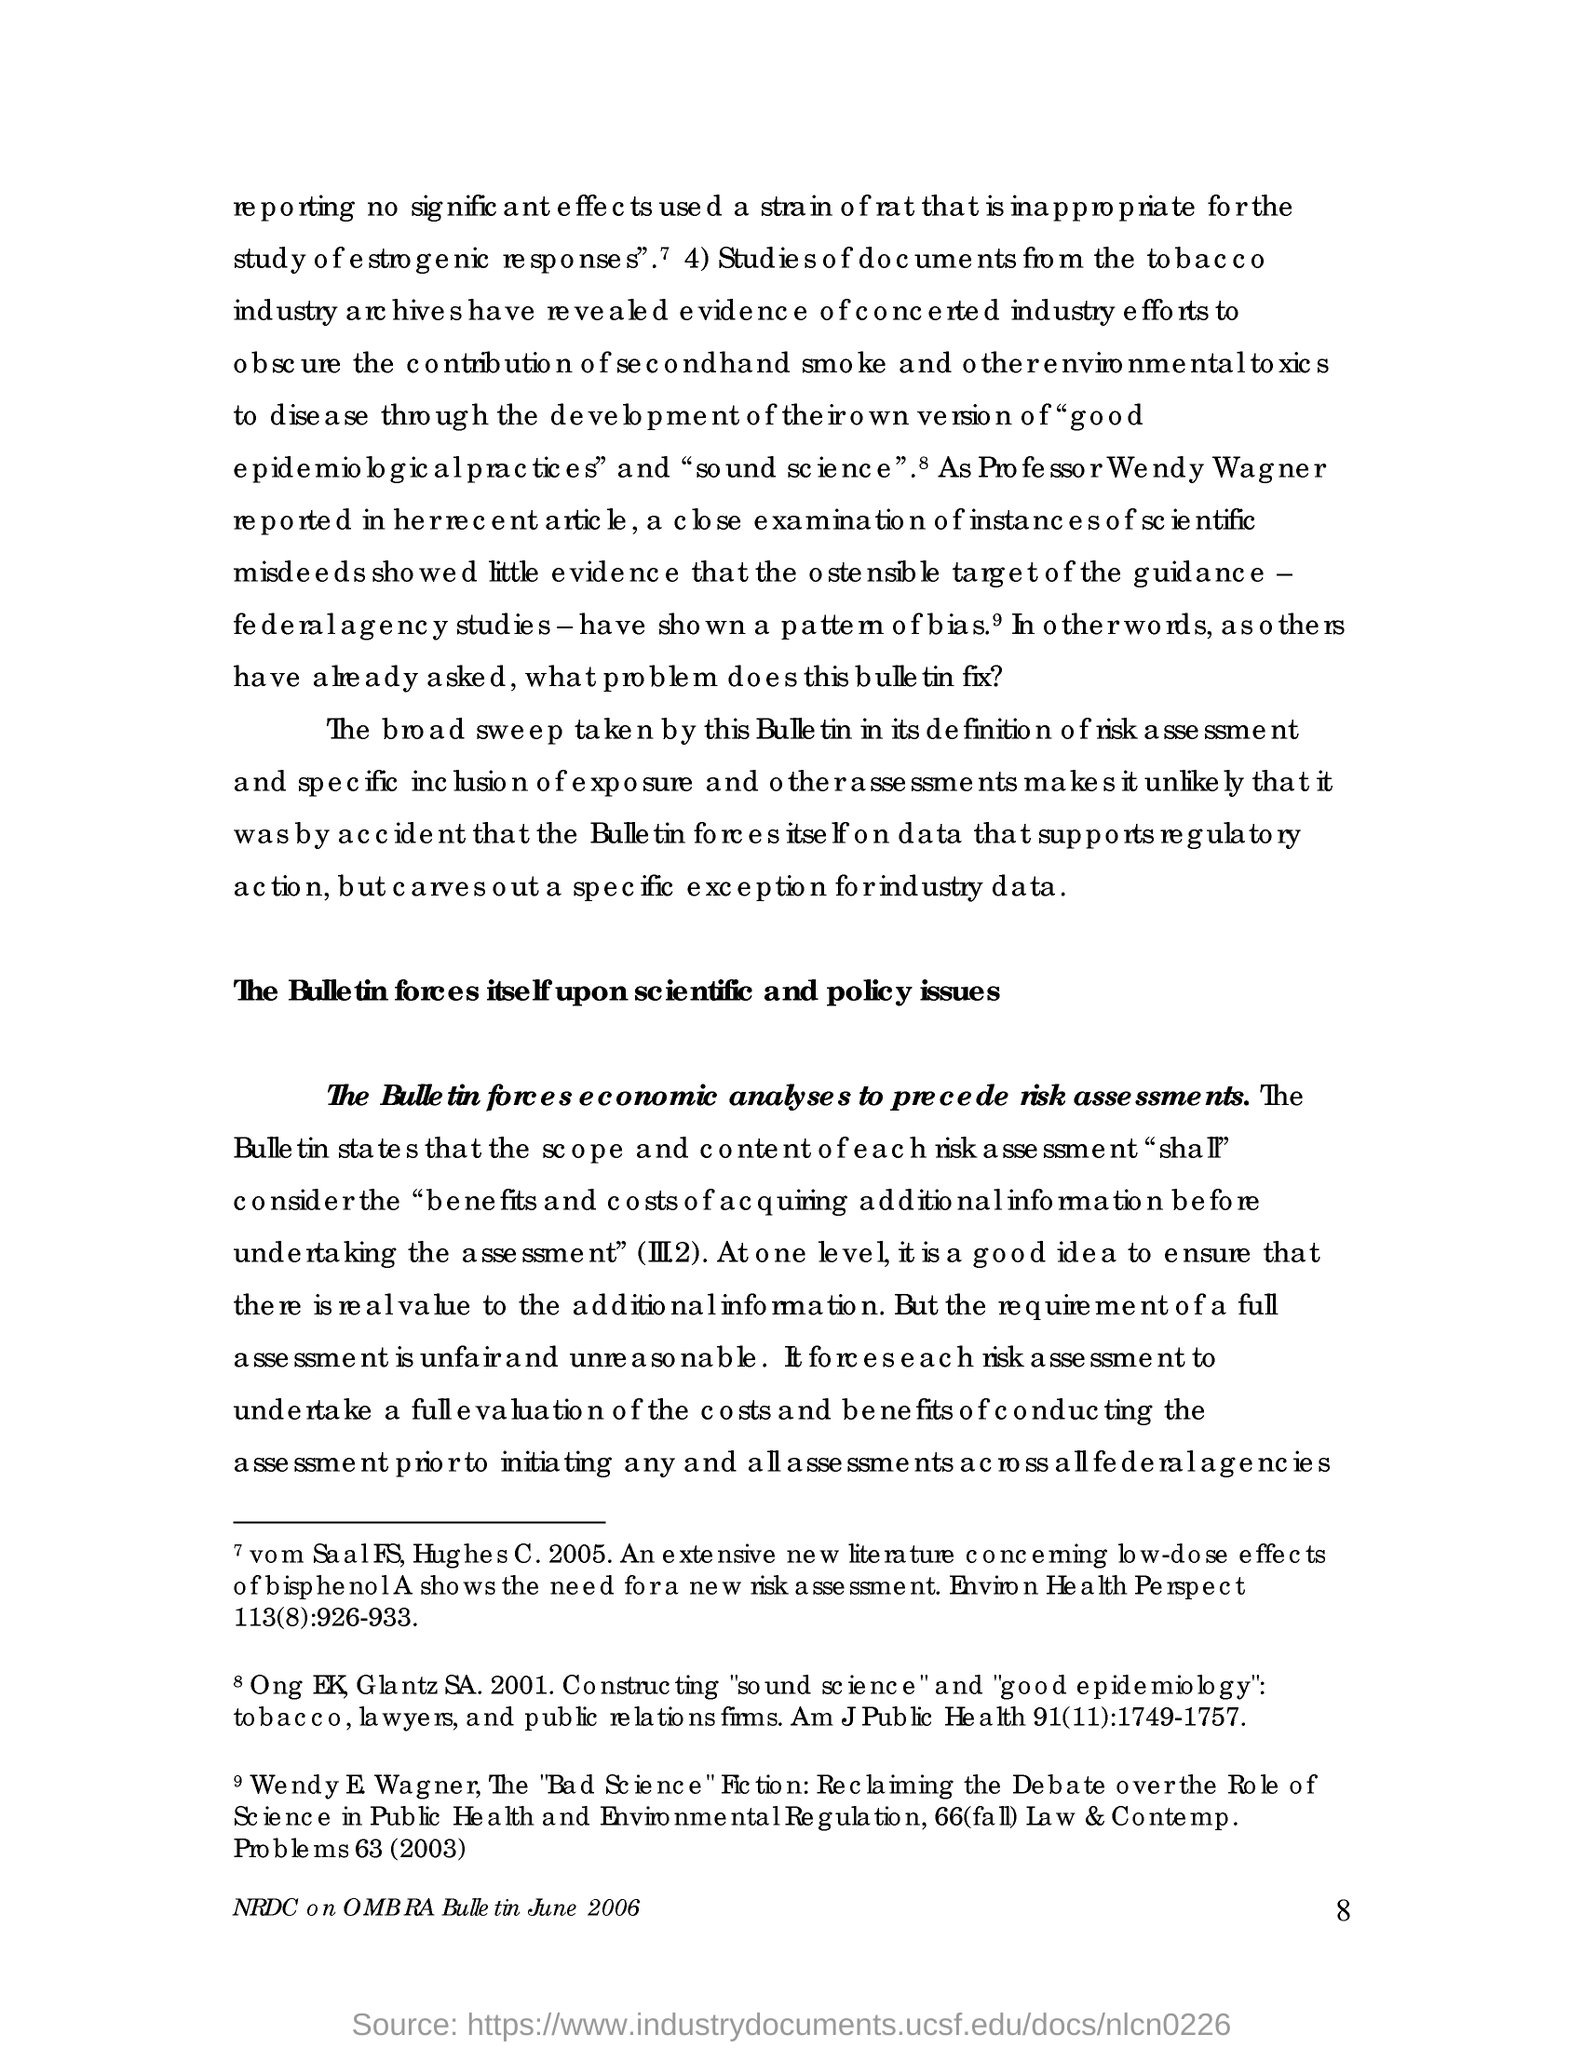Outline some significant characteristics in this image. The page number mentioned in this document is 8. 